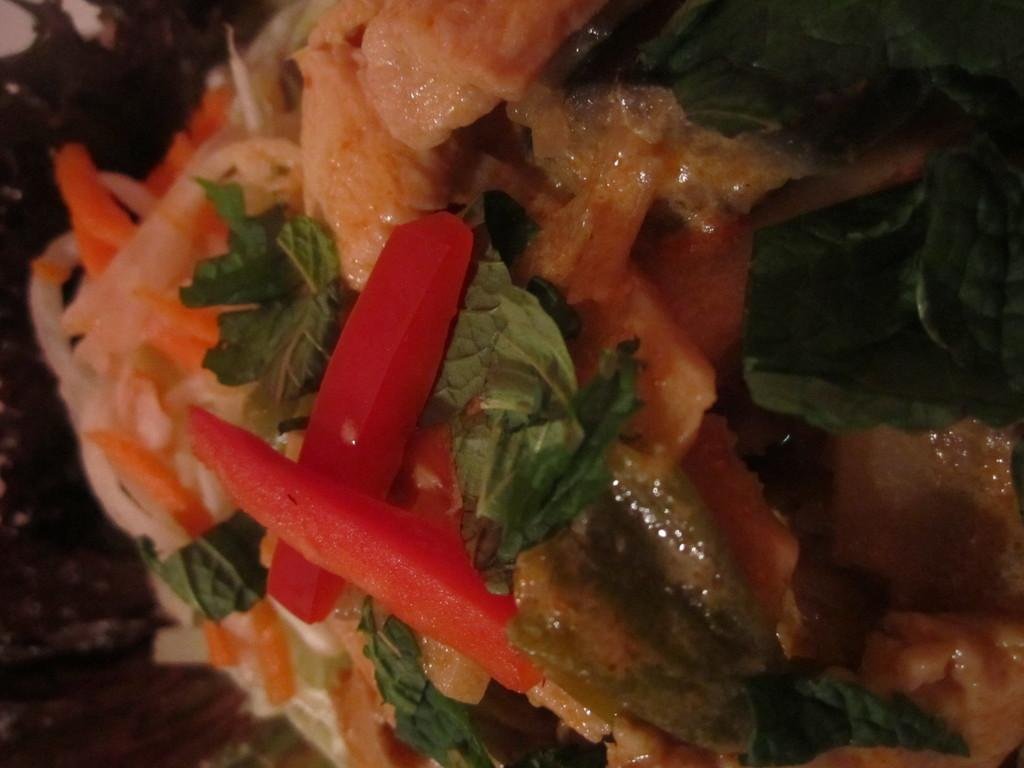What type of herb is present in the image? There is mint in the image. What type of food is present in the image? There is meat in the image. What type of fruit or vegetable is present in the image? There is a tomato in the image. What type of vegetable is present in the image? There is an onion in the image. What other unspecified objects can be seen on the plate in the image? There are other unspecified objects on the plate in the image. Can you tell me how many goldfish are swimming in the mint in the image? There are no goldfish present in the image; it features mint, meat, tomato, and onion. What type of toothpaste is used to clean the meat in the image? There is no toothpaste present in the image, and toothpaste is not used to clean meat. 